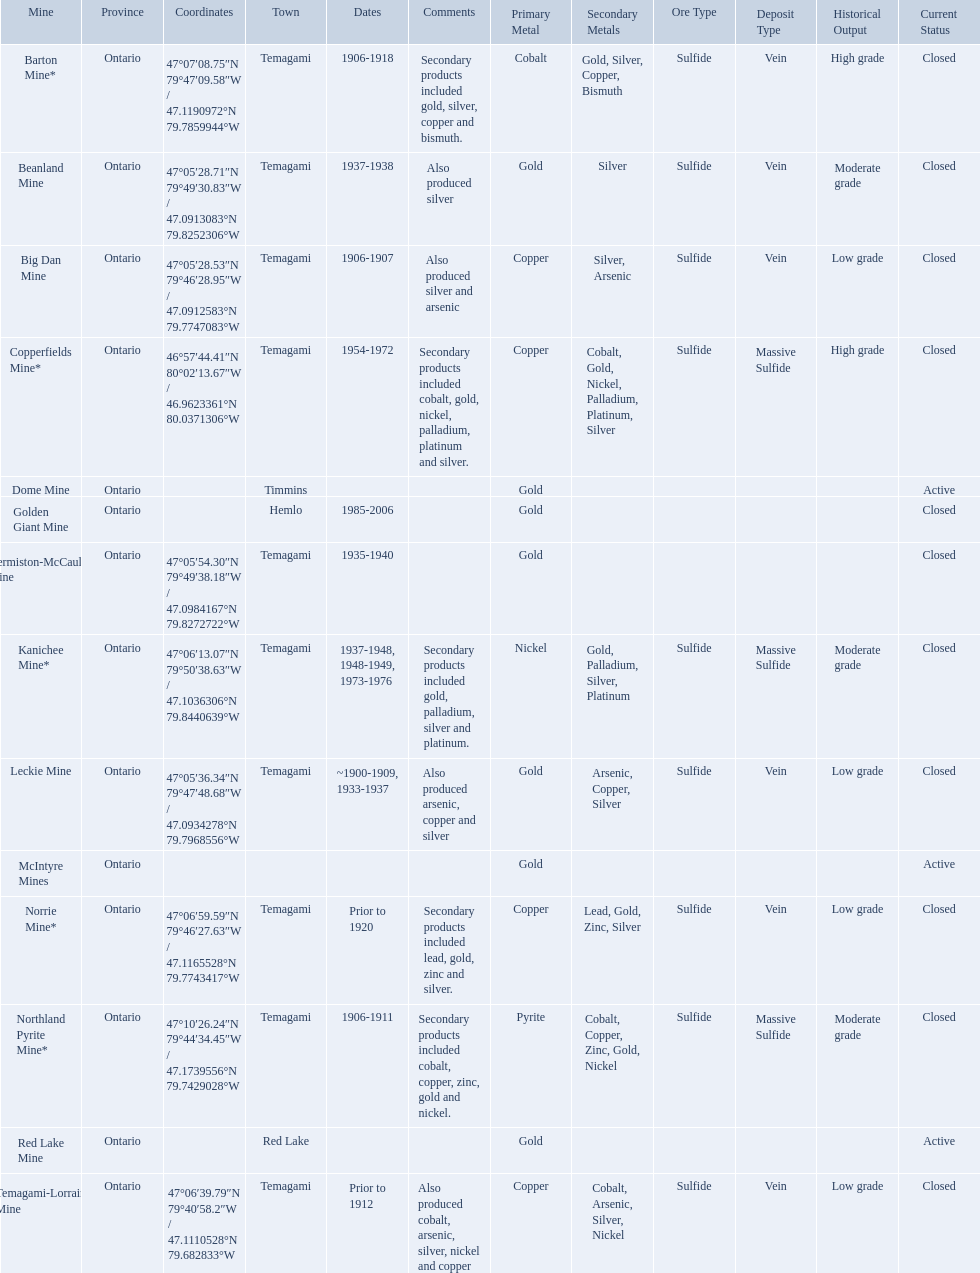What dates was the golden giant mine open? 1985-2006. What dates was the beanland mine open? 1937-1938. Of those mines, which was open longer? Golden Giant Mine. 